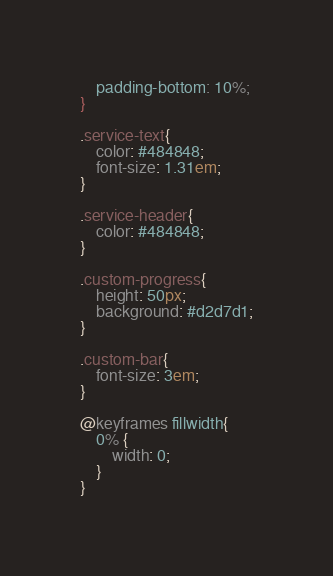<code> <loc_0><loc_0><loc_500><loc_500><_CSS_>	padding-bottom: 10%;
}

.service-text{
	color: #484848;
	font-size: 1.31em;
}

.service-header{
	color: #484848;
}

.custom-progress{
	height: 50px;
	background: #d2d7d1;
}

.custom-bar{
	font-size: 3em;
}

@keyframes fillwidth{ 
	0% {
		width: 0;
	}
}</code> 